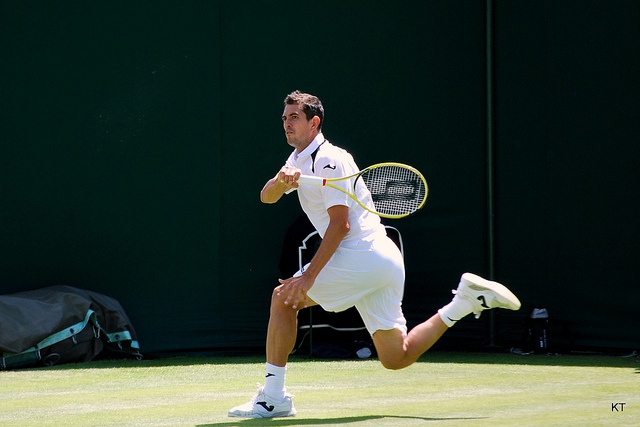Describe the objects in this image and their specific colors. I can see people in black, lightgray, darkgray, and maroon tones and tennis racket in black, lavender, gray, and darkgray tones in this image. 